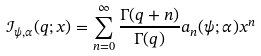Convert formula to latex. <formula><loc_0><loc_0><loc_500><loc_500>\mathcal { I } _ { \psi , \alpha } ( q ; x ) = \sum _ { n = 0 } ^ { \infty } \frac { \Gamma ( q + n ) } { \Gamma ( q ) } a _ { n } ( \psi ; \alpha ) x ^ { n }</formula> 